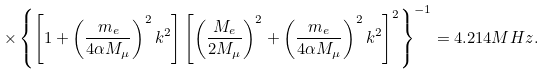<formula> <loc_0><loc_0><loc_500><loc_500>\times \left \{ \left [ 1 + \left ( \frac { m _ { e } } { 4 \alpha M _ { \mu } } \right ) ^ { 2 } k ^ { 2 } \right ] \left [ \left ( \frac { M _ { e } } { 2 M _ { \mu } } \right ) ^ { 2 } + \left ( \frac { m _ { e } } { 4 \alpha M _ { \mu } } \right ) ^ { 2 } k ^ { 2 } \right ] ^ { 2 } \right \} ^ { - 1 } = 4 . 2 1 4 M H z .</formula> 